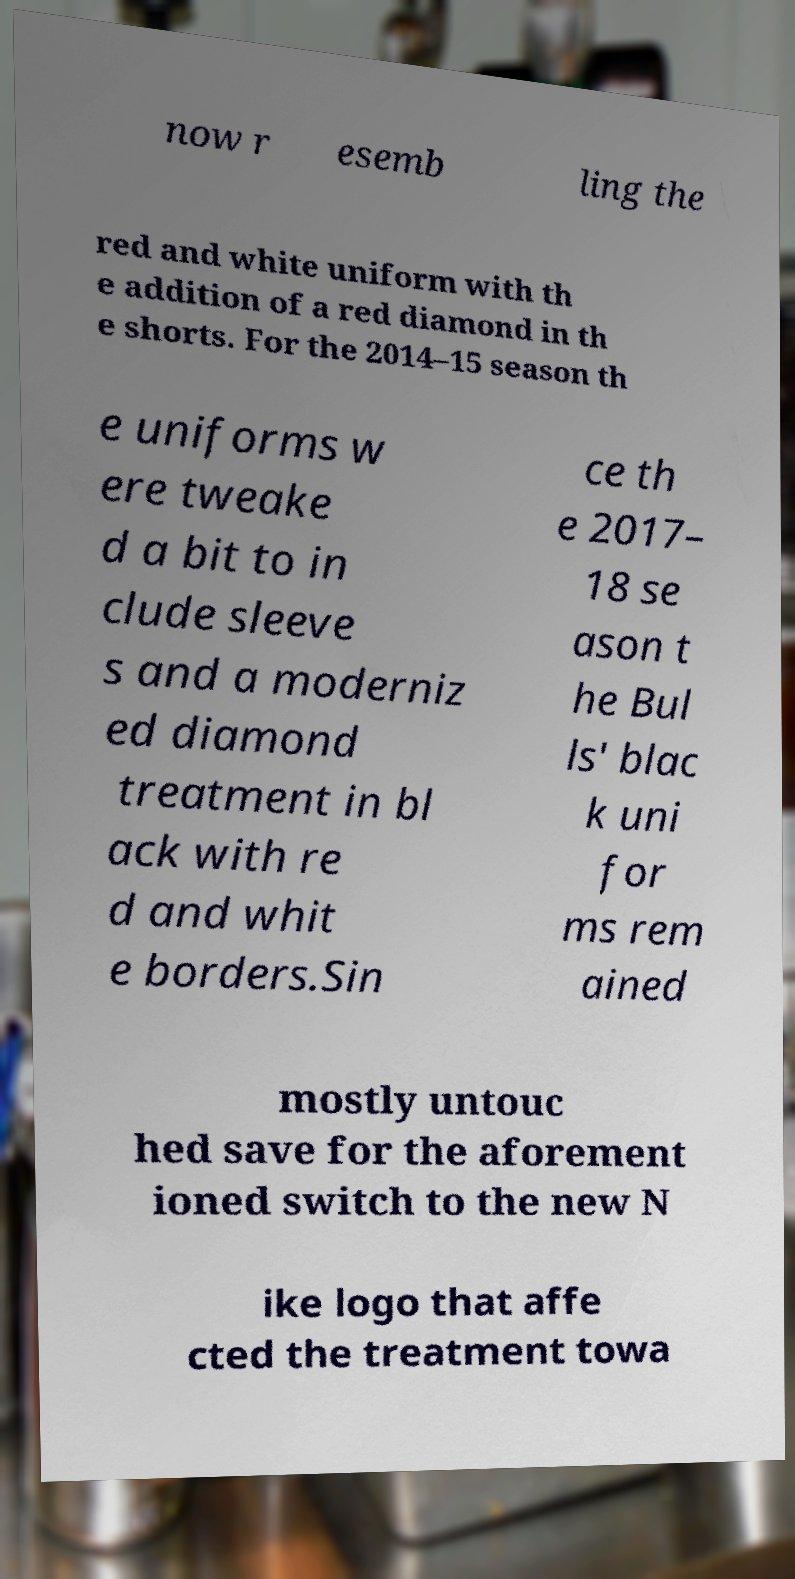There's text embedded in this image that I need extracted. Can you transcribe it verbatim? now r esemb ling the red and white uniform with th e addition of a red diamond in th e shorts. For the 2014–15 season th e uniforms w ere tweake d a bit to in clude sleeve s and a moderniz ed diamond treatment in bl ack with re d and whit e borders.Sin ce th e 2017– 18 se ason t he Bul ls' blac k uni for ms rem ained mostly untouc hed save for the aforement ioned switch to the new N ike logo that affe cted the treatment towa 